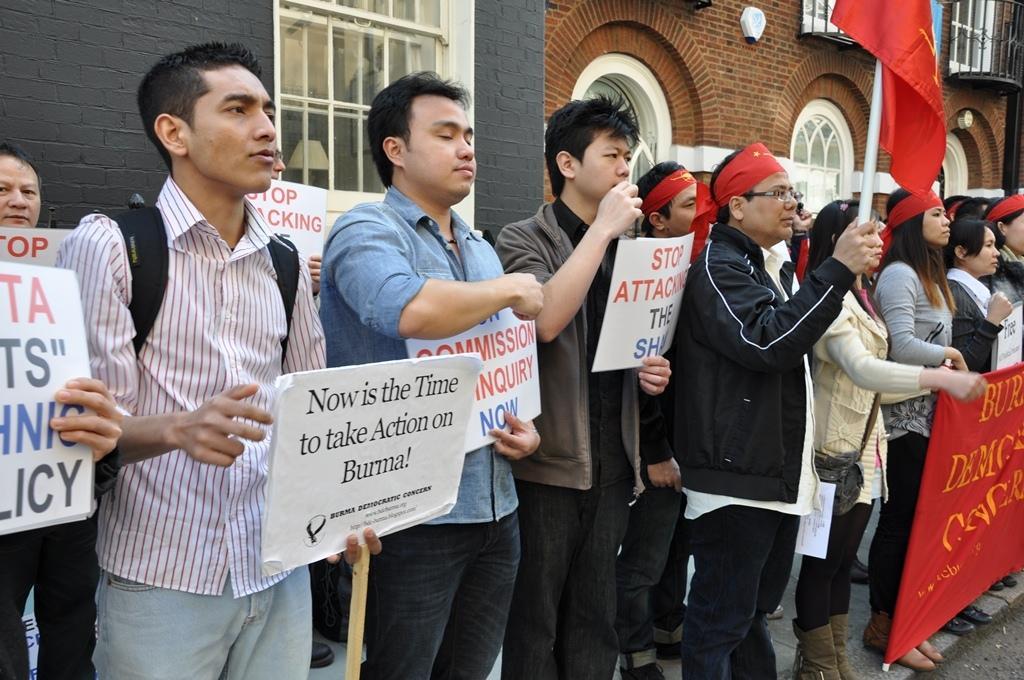Can you describe this image briefly? This image consists of many persons standing on the pavement. They are holding placards and flags along with banners. In the background, we can see buildings along with windows. At the bottom, there is a road. 